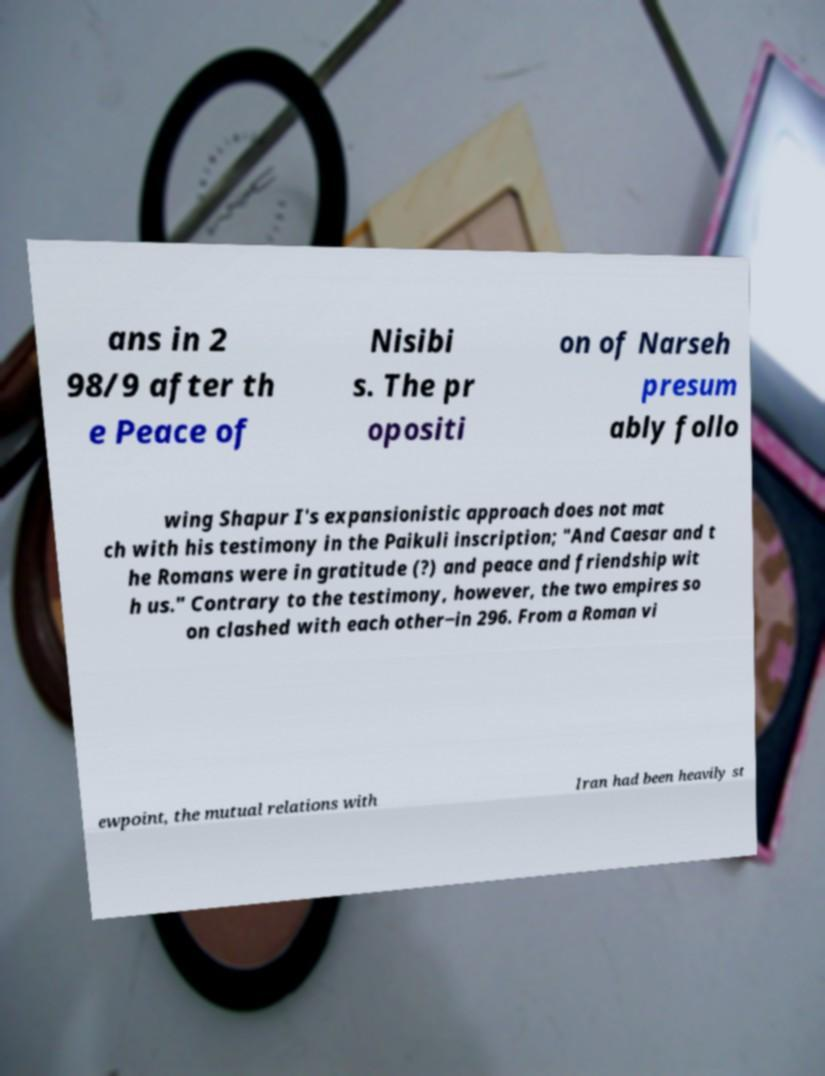I need the written content from this picture converted into text. Can you do that? ans in 2 98/9 after th e Peace of Nisibi s. The pr opositi on of Narseh presum ably follo wing Shapur I's expansionistic approach does not mat ch with his testimony in the Paikuli inscription; "And Caesar and t he Romans were in gratitude (?) and peace and friendship wit h us." Contrary to the testimony, however, the two empires so on clashed with each other−in 296. From a Roman vi ewpoint, the mutual relations with Iran had been heavily st 